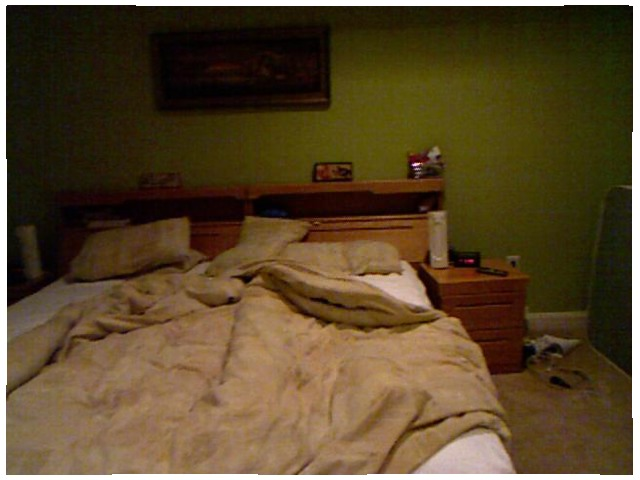<image>
Can you confirm if the bed is under the floor? No. The bed is not positioned under the floor. The vertical relationship between these objects is different. 